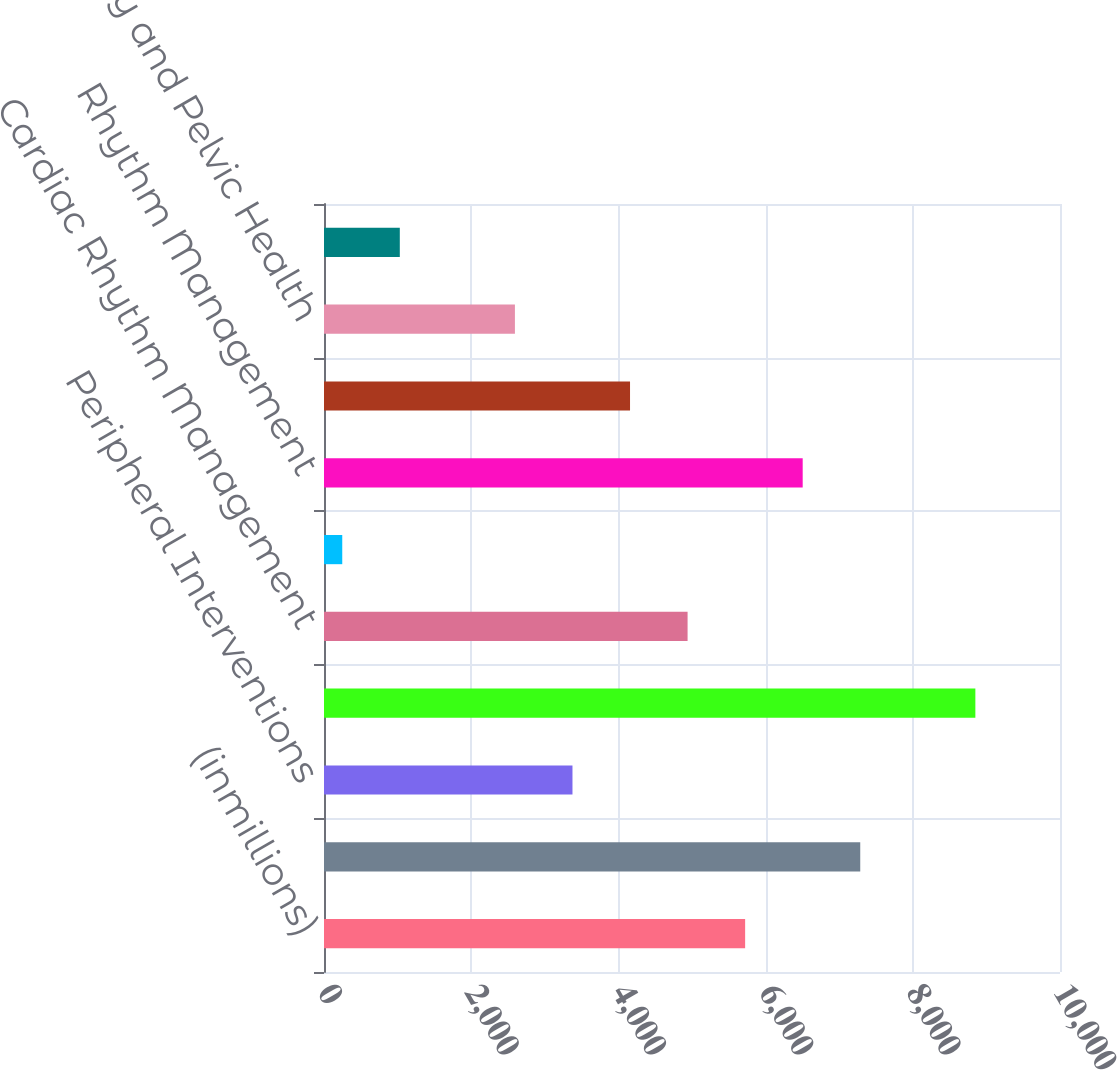Convert chart to OTSL. <chart><loc_0><loc_0><loc_500><loc_500><bar_chart><fcel>(inmillions)<fcel>Interventional Cardiology<fcel>Peripheral Interventions<fcel>Cardiovascular<fcel>Cardiac Rhythm Management<fcel>Electrophysiology<fcel>Rhythm Management<fcel>Endoscopy<fcel>Urology and Pelvic Health<fcel>Neuromodulation<nl><fcel>5722<fcel>7286<fcel>3376<fcel>8850<fcel>4940<fcel>248<fcel>6504<fcel>4158<fcel>2594<fcel>1030<nl></chart> 